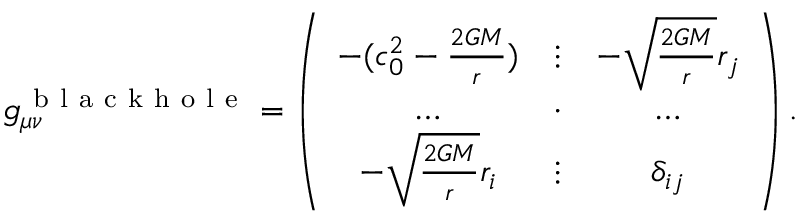Convert formula to latex. <formula><loc_0><loc_0><loc_500><loc_500>g _ { \mu \nu } ^ { b l a c k h o l e } = \left ( \begin{array} { c c c } { - ( c _ { 0 } ^ { 2 } - \frac { 2 G M } { r } ) } & { \vdots } & { - \sqrt { \frac { 2 G M } { r } } { r _ { j } } } \\ { \dots } & { \cdot } & { \dots } \\ { - \sqrt { \frac { 2 G M } { r } } { r _ { i } } } & { \vdots } & { \delta _ { i j } } \end{array} \right ) .</formula> 